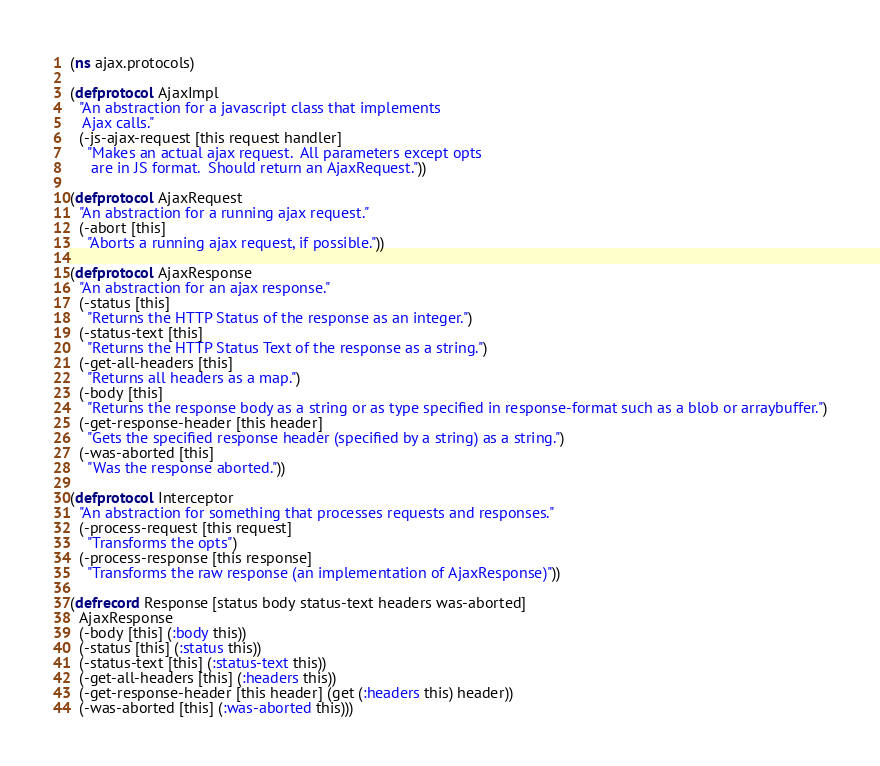<code> <loc_0><loc_0><loc_500><loc_500><_Clojure_>(ns ajax.protocols)

(defprotocol AjaxImpl
  "An abstraction for a javascript class that implements
   Ajax calls."
  (-js-ajax-request [this request handler]
    "Makes an actual ajax request.  All parameters except opts
     are in JS format.  Should return an AjaxRequest."))

(defprotocol AjaxRequest
  "An abstraction for a running ajax request."
  (-abort [this]
    "Aborts a running ajax request, if possible."))

(defprotocol AjaxResponse
  "An abstraction for an ajax response."
  (-status [this]
    "Returns the HTTP Status of the response as an integer.")
  (-status-text [this]
    "Returns the HTTP Status Text of the response as a string.")
  (-get-all-headers [this]
    "Returns all headers as a map.")
  (-body [this]
    "Returns the response body as a string or as type specified in response-format such as a blob or arraybuffer.")
  (-get-response-header [this header]
    "Gets the specified response header (specified by a string) as a string.")
  (-was-aborted [this]
    "Was the response aborted."))

(defprotocol Interceptor
  "An abstraction for something that processes requests and responses."
  (-process-request [this request]
    "Transforms the opts")
  (-process-response [this response]
    "Transforms the raw response (an implementation of AjaxResponse)"))

(defrecord Response [status body status-text headers was-aborted]
  AjaxResponse
  (-body [this] (:body this))
  (-status [this] (:status this))
  (-status-text [this] (:status-text this))
  (-get-all-headers [this] (:headers this))
  (-get-response-header [this header] (get (:headers this) header))
  (-was-aborted [this] (:was-aborted this)))
</code> 